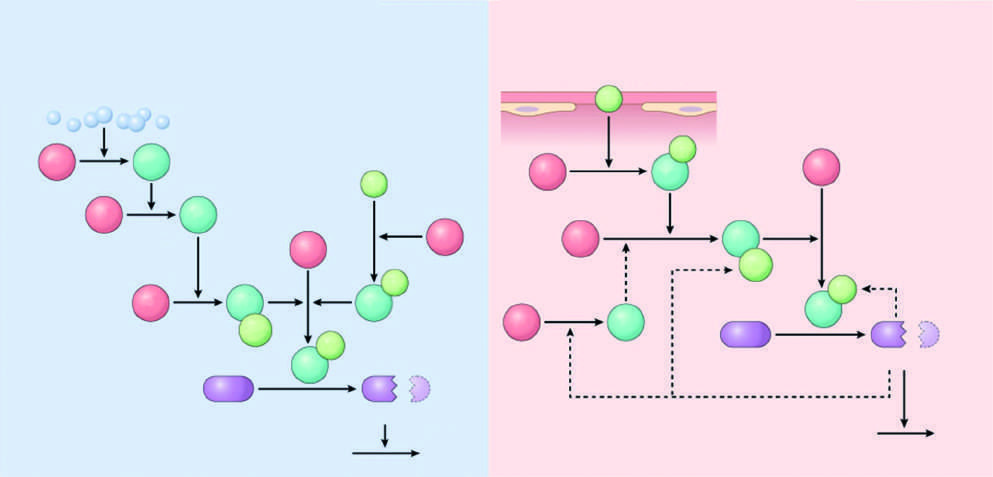what are inactive factors?
Answer the question using a single word or phrase. The red polypeptides 